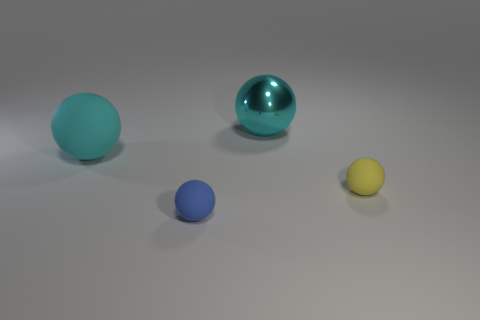There is a cyan ball on the left side of the cyan metallic object; what number of cyan metallic balls are in front of it?
Make the answer very short. 0. There is a small rubber sphere on the left side of the tiny yellow thing; is its color the same as the big matte ball?
Make the answer very short. No. Are there any metallic objects in front of the large cyan object right of the rubber thing that is in front of the yellow rubber object?
Your answer should be compact. No. There is a object that is right of the blue sphere and in front of the big cyan metal ball; what is its shape?
Your answer should be compact. Sphere. Are there any small cylinders that have the same color as the big rubber object?
Your answer should be compact. No. There is a small sphere right of the rubber object in front of the yellow matte sphere; what color is it?
Offer a very short reply. Yellow. There is a ball behind the ball left of the tiny matte ball that is to the left of the yellow rubber sphere; what size is it?
Your response must be concise. Large. Does the tiny yellow ball have the same material as the tiny sphere that is left of the yellow rubber sphere?
Your answer should be very brief. Yes. What is the size of the cyan thing that is made of the same material as the tiny yellow sphere?
Offer a terse response. Large. Are there any other shiny things of the same shape as the metallic object?
Make the answer very short. No. 